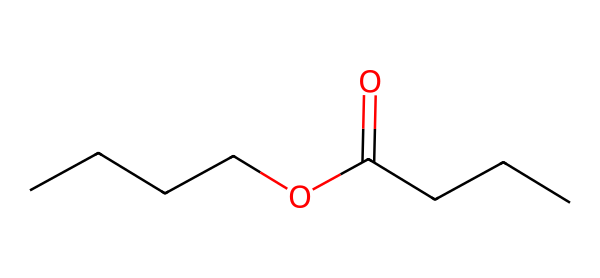What is the total number of carbon atoms in butyl butyrate? In the SMILES representation "CCCCOC(=O)CCC", there are four carbon atoms in the "CCCC" part, and three carbon atoms in "CCC". Combining these, the total is seven carbon atoms.
Answer: seven What functional groups are present in butyl butyrate? The structure shows an ester functional group, indicated by the "OC(=O)" part of the SMILES, and a chain of carbon alkyl groups. The "C(=O)" indicates a carbonyl group, which is part of the ester structure.
Answer: ester What type of bond connects the carbonyl carbon to the oxygen in butyl butyrate? In the structure, the bond between the carbonyl carbon (C=O) and the oxygen (O) is a double bond (noted as =O), while the bond connecting this carbon to the alkyl group is a single bond.
Answer: double bond How many hydrogen atoms are present in butyl butyrate? To determine the number of hydrogens, we consider that each carbon typically forms four bonds. Counting the bonds to other carbons and the oxygen, we deduce that there are 14 hydrogen atoms attached.
Answer: fourteen What is the primary reason butyl butyrate is associated with pineapple fragrances? Butyl butyrate is an ester, and esters are often responsible for fruity and sweet aromas due to their molecular structure, which resembles those found in natural fruit scents.
Answer: fruity aroma How many oxygen atoms are present in butyl butyrate? The SMILES notation shows one oxygen in the carbonyl group (C=O) and one oxygen in the ester linkage (–O–), leading to a total of two oxygen atoms.
Answer: two 